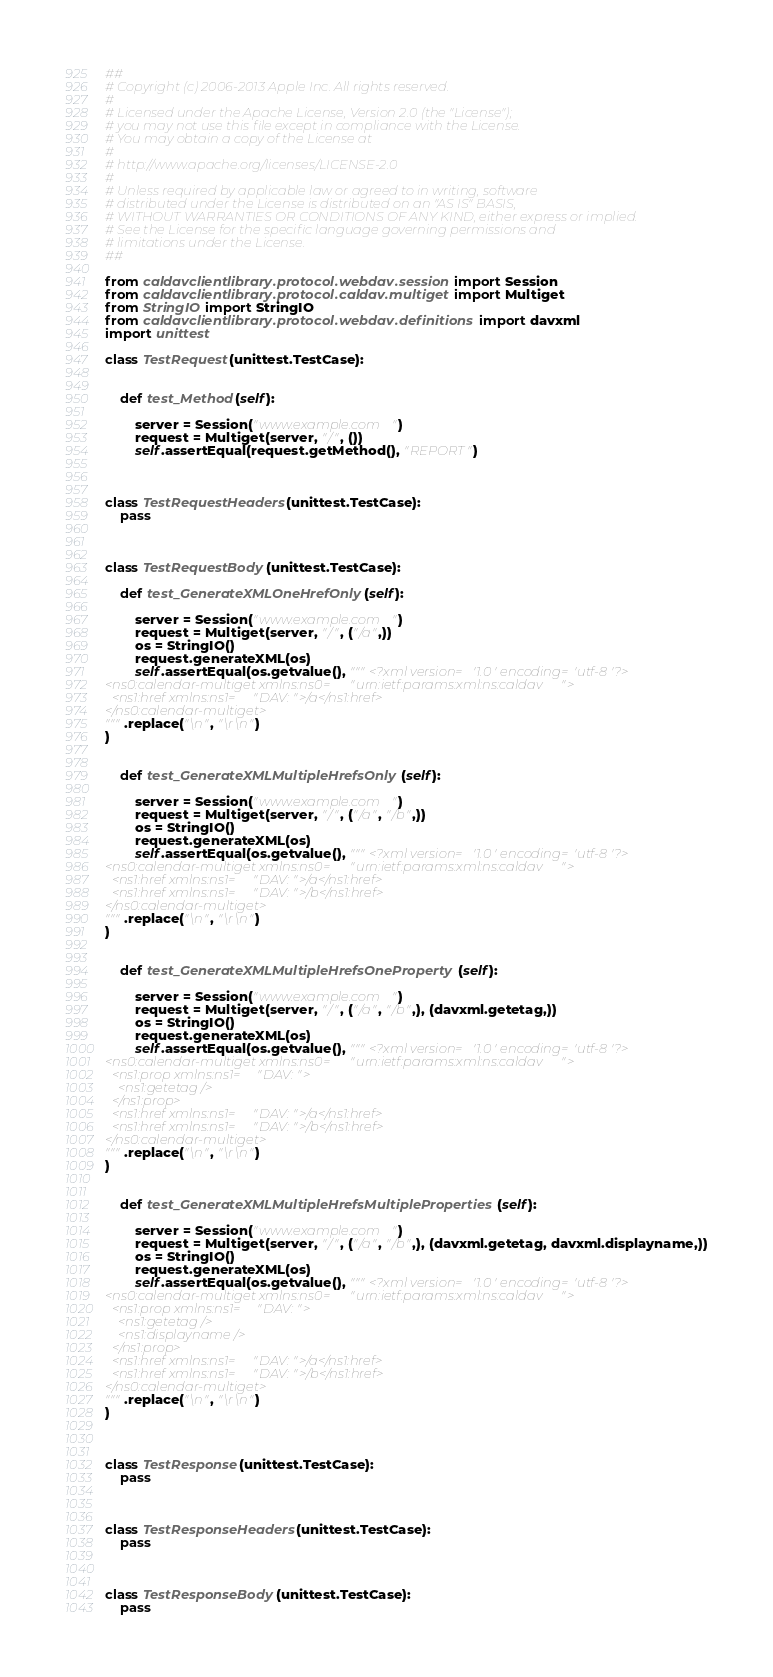Convert code to text. <code><loc_0><loc_0><loc_500><loc_500><_Python_>##
# Copyright (c) 2006-2013 Apple Inc. All rights reserved.
#
# Licensed under the Apache License, Version 2.0 (the "License");
# you may not use this file except in compliance with the License.
# You may obtain a copy of the License at
#
# http://www.apache.org/licenses/LICENSE-2.0
#
# Unless required by applicable law or agreed to in writing, software
# distributed under the License is distributed on an "AS IS" BASIS,
# WITHOUT WARRANTIES OR CONDITIONS OF ANY KIND, either express or implied.
# See the License for the specific language governing permissions and
# limitations under the License.
##

from caldavclientlibrary.protocol.webdav.session import Session
from caldavclientlibrary.protocol.caldav.multiget import Multiget
from StringIO import StringIO
from caldavclientlibrary.protocol.webdav.definitions import davxml
import unittest

class TestRequest(unittest.TestCase):


    def test_Method(self):

        server = Session("www.example.com")
        request = Multiget(server, "/", ())
        self.assertEqual(request.getMethod(), "REPORT")



class TestRequestHeaders(unittest.TestCase):
    pass



class TestRequestBody(unittest.TestCase):

    def test_GenerateXMLOneHrefOnly(self):

        server = Session("www.example.com")
        request = Multiget(server, "/", ("/a",))
        os = StringIO()
        request.generateXML(os)
        self.assertEqual(os.getvalue(), """<?xml version='1.0' encoding='utf-8'?>
<ns0:calendar-multiget xmlns:ns0="urn:ietf:params:xml:ns:caldav">
  <ns1:href xmlns:ns1="DAV:">/a</ns1:href>
</ns0:calendar-multiget>
""".replace("\n", "\r\n")
)


    def test_GenerateXMLMultipleHrefsOnly(self):

        server = Session("www.example.com")
        request = Multiget(server, "/", ("/a", "/b",))
        os = StringIO()
        request.generateXML(os)
        self.assertEqual(os.getvalue(), """<?xml version='1.0' encoding='utf-8'?>
<ns0:calendar-multiget xmlns:ns0="urn:ietf:params:xml:ns:caldav">
  <ns1:href xmlns:ns1="DAV:">/a</ns1:href>
  <ns1:href xmlns:ns1="DAV:">/b</ns1:href>
</ns0:calendar-multiget>
""".replace("\n", "\r\n")
)


    def test_GenerateXMLMultipleHrefsOneProperty(self):

        server = Session("www.example.com")
        request = Multiget(server, "/", ("/a", "/b",), (davxml.getetag,))
        os = StringIO()
        request.generateXML(os)
        self.assertEqual(os.getvalue(), """<?xml version='1.0' encoding='utf-8'?>
<ns0:calendar-multiget xmlns:ns0="urn:ietf:params:xml:ns:caldav">
  <ns1:prop xmlns:ns1="DAV:">
    <ns1:getetag />
  </ns1:prop>
  <ns1:href xmlns:ns1="DAV:">/a</ns1:href>
  <ns1:href xmlns:ns1="DAV:">/b</ns1:href>
</ns0:calendar-multiget>
""".replace("\n", "\r\n")
)


    def test_GenerateXMLMultipleHrefsMultipleProperties(self):

        server = Session("www.example.com")
        request = Multiget(server, "/", ("/a", "/b",), (davxml.getetag, davxml.displayname,))
        os = StringIO()
        request.generateXML(os)
        self.assertEqual(os.getvalue(), """<?xml version='1.0' encoding='utf-8'?>
<ns0:calendar-multiget xmlns:ns0="urn:ietf:params:xml:ns:caldav">
  <ns1:prop xmlns:ns1="DAV:">
    <ns1:getetag />
    <ns1:displayname />
  </ns1:prop>
  <ns1:href xmlns:ns1="DAV:">/a</ns1:href>
  <ns1:href xmlns:ns1="DAV:">/b</ns1:href>
</ns0:calendar-multiget>
""".replace("\n", "\r\n")
)



class TestResponse(unittest.TestCase):
    pass



class TestResponseHeaders(unittest.TestCase):
    pass



class TestResponseBody(unittest.TestCase):
    pass
</code> 